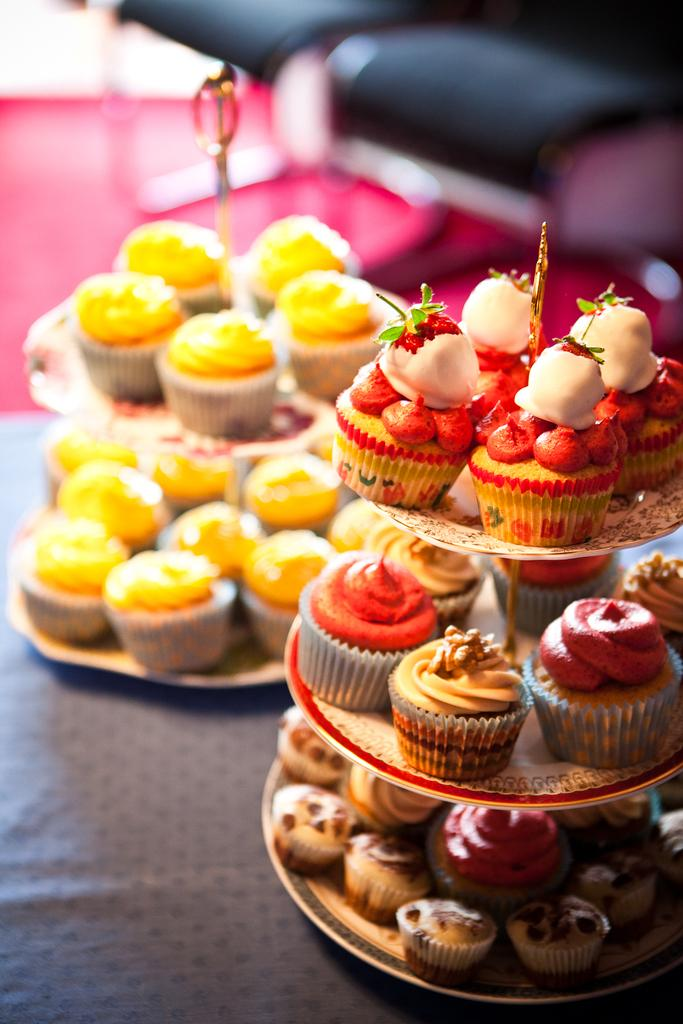What type of dessert can be seen in the image? There are cupcakes ines in the image. How many different types of cupcakes are present? The cupcakes are of different kinds. How are the cupcakes arranged or displayed? The cupcakes are placed in cake stands. What type of wood can be seen in the image? There is no wood present in the image; it features cupcakes placed in cake stands. 